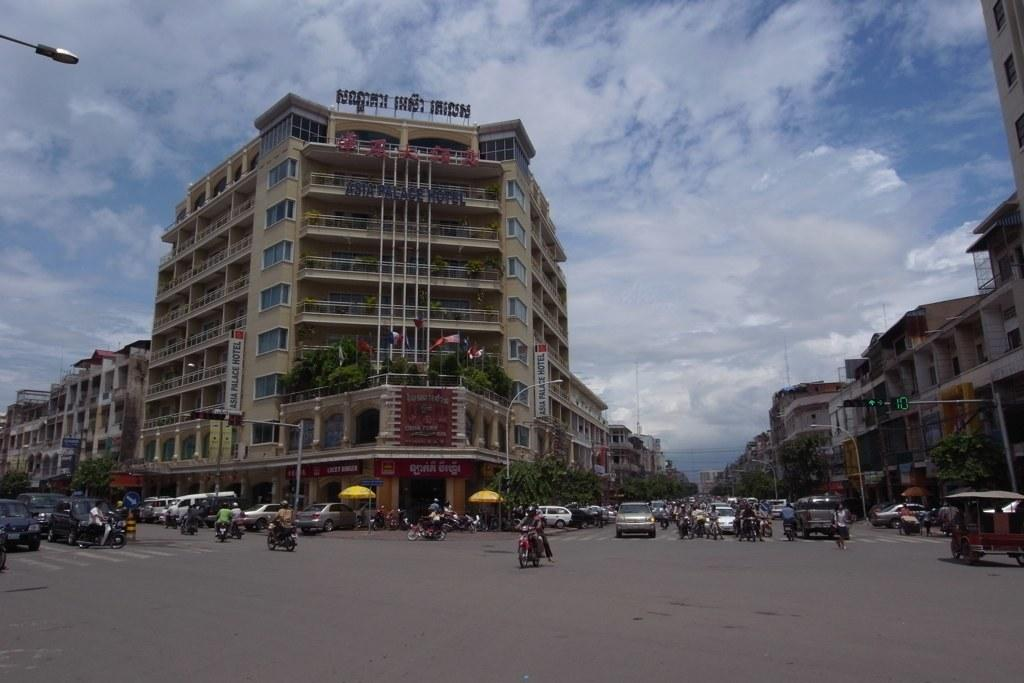What can be seen on the road in the image? There are vehicles on the road in the image. What else is present in the image besides the vehicles? There is a group of people, umbrellas, poles, lights, flags with poles, trees, buildings, and the sky is visible in the background. Can you describe the group of people in the image? The group of people is not specified, but they are present in the image. What type of structures are visible in the image? Buildings are visible in the image. What is the brain of the person in the image thinking? There is no information about the thoughts of any person in the image, nor is there any indication of a brain being visible. How does the porter assist the group of people in the image? There is no porter present in the image, so it is not possible to answer this question. 